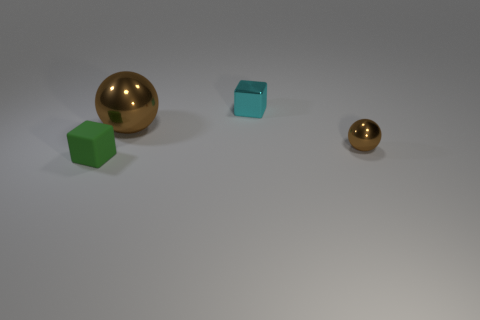The other metallic ball that is the same color as the large shiny ball is what size?
Provide a succinct answer. Small. There is a metal thing that is left of the tiny block that is behind the green rubber block; is there a cyan object in front of it?
Provide a succinct answer. No. There is a tiny metallic cube; how many small brown things are in front of it?
Your response must be concise. 1. What number of other things are the same color as the big thing?
Ensure brevity in your answer.  1. What number of things are either blocks behind the tiny matte cube or tiny objects that are behind the small brown thing?
Keep it short and to the point. 1. Are there more brown objects than green cubes?
Your answer should be very brief. Yes. There is a tiny block that is in front of the tiny brown thing; what is its color?
Your answer should be compact. Green. Is the small cyan object the same shape as the small brown metallic object?
Offer a terse response. No. There is a small object that is in front of the cyan metal cube and behind the green object; what color is it?
Make the answer very short. Brown. There is a brown metal ball that is behind the small brown object; is it the same size as the metallic ball in front of the large brown ball?
Provide a succinct answer. No. 